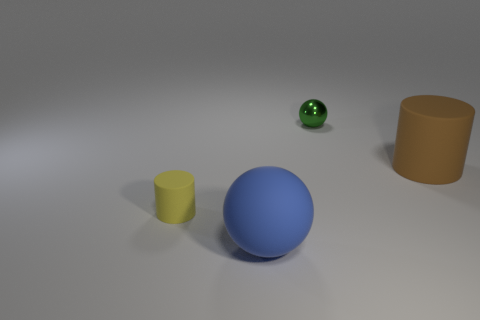What materials do the objects in the image seem to be made of? While I can't physically interact with the objects to determine their material, based on their appearance, the objects in the image—a blue sphere, a green sphere, a yellow cylinder, and a brown cylinder—seem to be made of a matte plastic. Their surfaces have a slight sheen typical of plastic materials, although lighting and rendering techniques could also influence their appearance. 